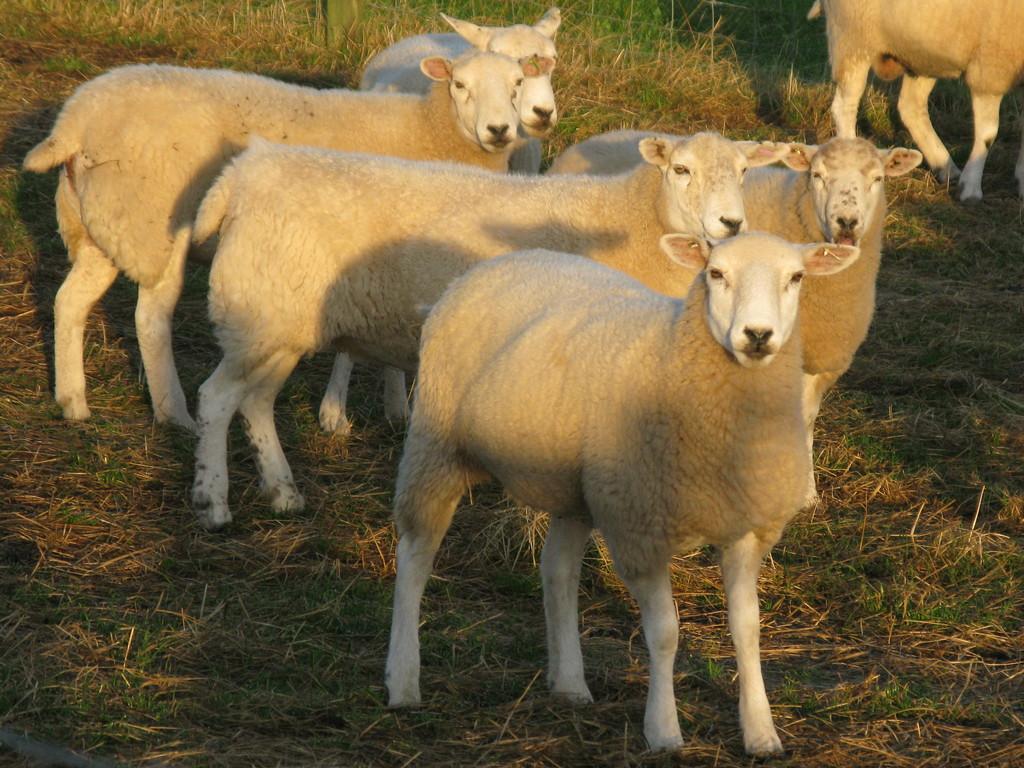Please provide a concise description of this image. In this image we can see some animals and we can see the grass on the ground. 